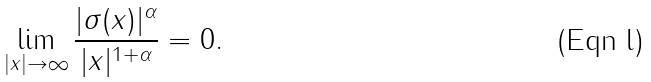<formula> <loc_0><loc_0><loc_500><loc_500>\lim _ { | x | \to \infty } \frac { | \sigma ( x ) | ^ { \alpha } } { | x | ^ { 1 + \alpha } } = 0 .</formula> 